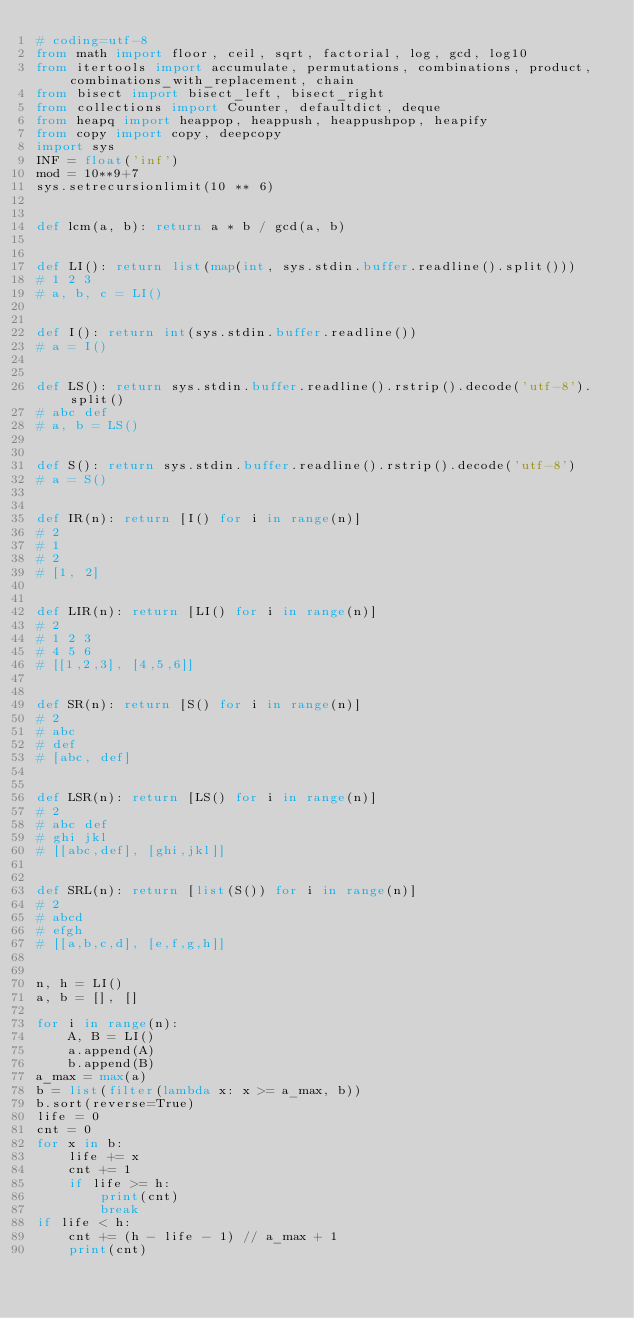Convert code to text. <code><loc_0><loc_0><loc_500><loc_500><_Python_># coding=utf-8
from math import floor, ceil, sqrt, factorial, log, gcd, log10
from itertools import accumulate, permutations, combinations, product, combinations_with_replacement, chain
from bisect import bisect_left, bisect_right
from collections import Counter, defaultdict, deque
from heapq import heappop, heappush, heappushpop, heapify
from copy import copy, deepcopy
import sys
INF = float('inf')
mod = 10**9+7
sys.setrecursionlimit(10 ** 6)


def lcm(a, b): return a * b / gcd(a, b)


def LI(): return list(map(int, sys.stdin.buffer.readline().split()))
# 1 2 3
# a, b, c = LI()


def I(): return int(sys.stdin.buffer.readline())
# a = I()


def LS(): return sys.stdin.buffer.readline().rstrip().decode('utf-8').split()
# abc def
# a, b = LS()


def S(): return sys.stdin.buffer.readline().rstrip().decode('utf-8')
# a = S()


def IR(n): return [I() for i in range(n)]
# 2
# 1
# 2
# [1, 2]


def LIR(n): return [LI() for i in range(n)]
# 2
# 1 2 3
# 4 5 6
# [[1,2,3], [4,5,6]]


def SR(n): return [S() for i in range(n)]
# 2
# abc
# def
# [abc, def]


def LSR(n): return [LS() for i in range(n)]
# 2
# abc def
# ghi jkl
# [[abc,def], [ghi,jkl]]


def SRL(n): return [list(S()) for i in range(n)]
# 2
# abcd
# efgh
# [[a,b,c,d], [e,f,g,h]]


n, h = LI()
a, b = [], []

for i in range(n):
    A, B = LI()
    a.append(A)
    b.append(B)
a_max = max(a)
b = list(filter(lambda x: x >= a_max, b))
b.sort(reverse=True)
life = 0
cnt = 0
for x in b:
    life += x
    cnt += 1
    if life >= h:
        print(cnt)
        break
if life < h:
    cnt += (h - life - 1) // a_max + 1
    print(cnt)
</code> 